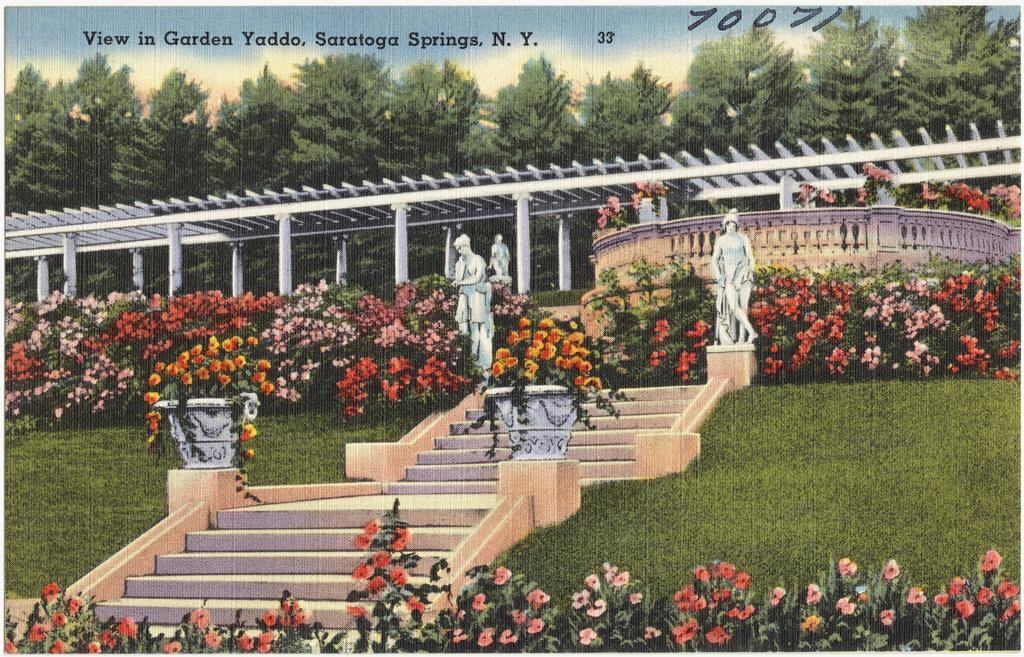Provide a one-sentence caption for the provided image. A painting of stairs that says it is of Graden Yaddo of Saratoga Springs. 